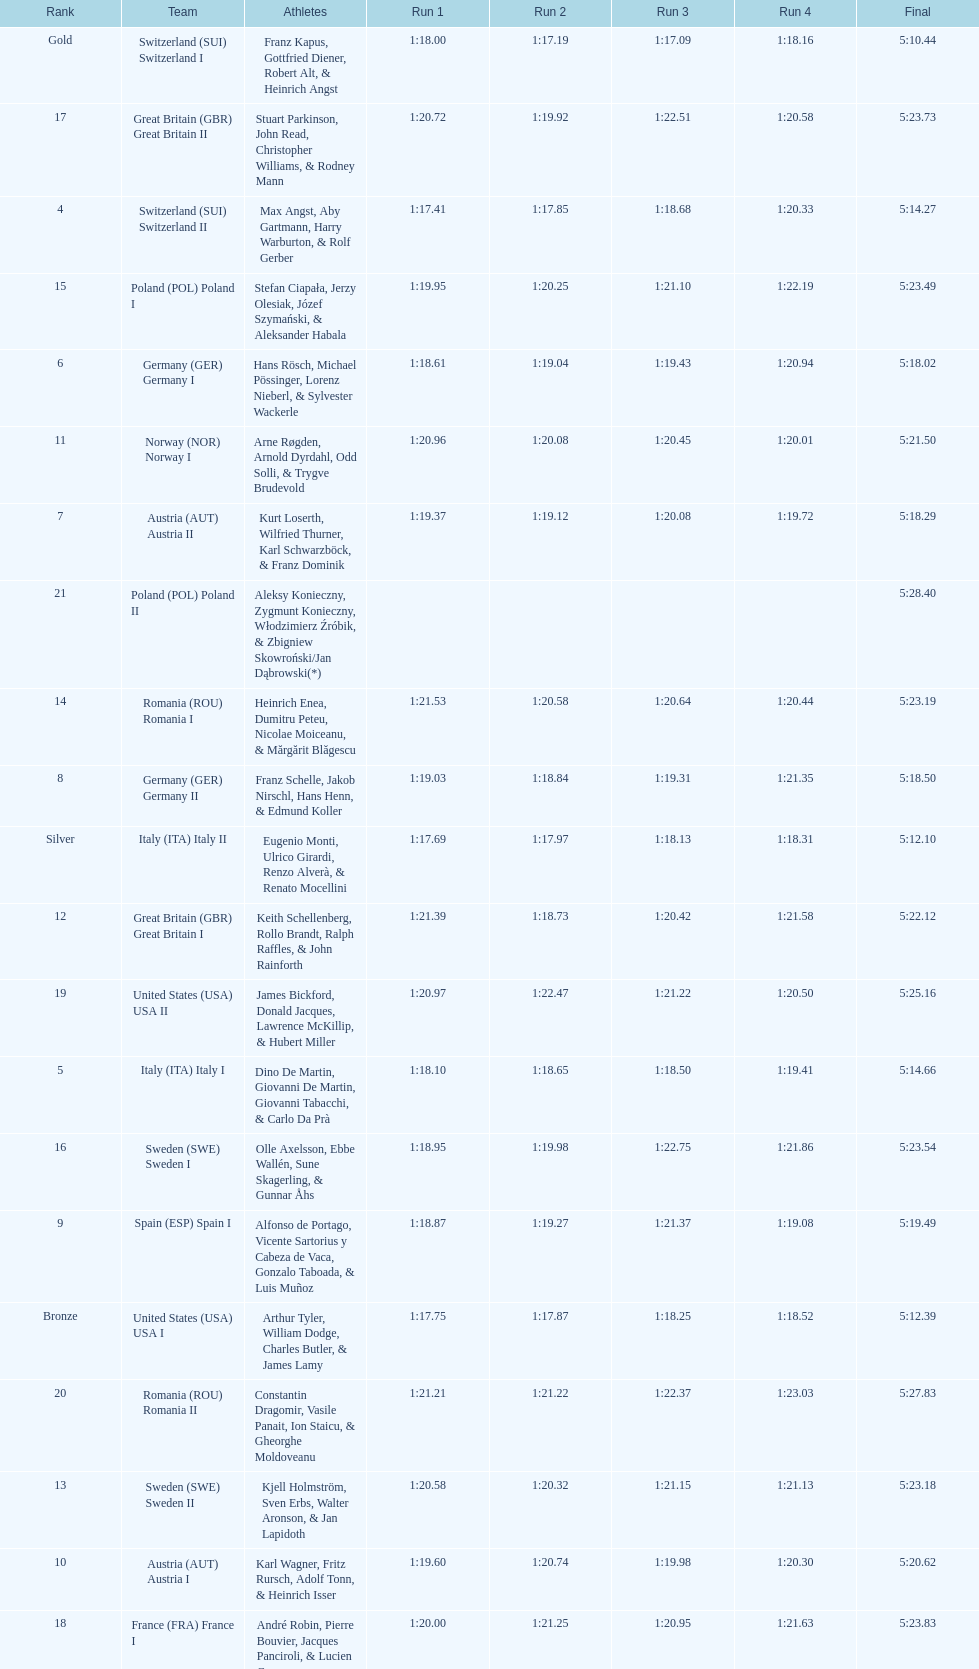How many teams did germany have? 2. 